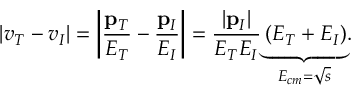Convert formula to latex. <formula><loc_0><loc_0><loc_500><loc_500>\left | v _ { T } - v _ { I } \right | = \left | \frac { p _ { T } } { E _ { T } } - \frac { p _ { I } } { E _ { I } } \right | = \frac { \left | p _ { I } \right | } { E _ { T } E _ { I } } \underset { E _ { c m } = \sqrt { s } } { \underbrace { \left ( E _ { T } + E _ { I } \right ) } } .</formula> 